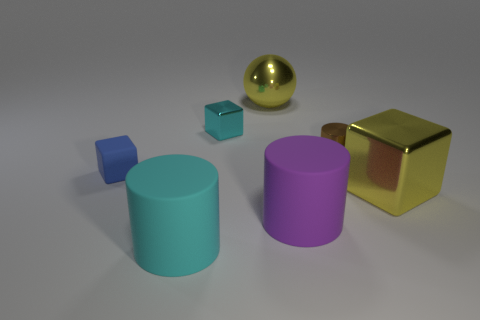There is a small brown thing; does it have the same shape as the cyan thing in front of the blue rubber object?
Make the answer very short. Yes. Are there any yellow shiny objects?
Make the answer very short. Yes. How many small objects are cyan matte objects or rubber cylinders?
Offer a terse response. 0. Are there more cyan metallic cubes in front of the tiny blue object than purple cylinders on the right side of the shiny cylinder?
Your answer should be very brief. No. Are the blue thing and the cyan object that is in front of the blue rubber block made of the same material?
Your answer should be very brief. Yes. The shiny cylinder is what color?
Keep it short and to the point. Brown. There is a big yellow object in front of the metal ball; what is its shape?
Give a very brief answer. Cube. What number of blue objects are rubber blocks or small shiny cylinders?
Give a very brief answer. 1. What is the color of the large sphere that is the same material as the small cyan thing?
Your answer should be very brief. Yellow. There is a large metal ball; does it have the same color as the large metal object right of the big metallic sphere?
Offer a terse response. Yes. 